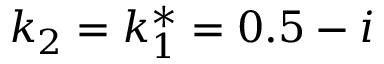<formula> <loc_0><loc_0><loc_500><loc_500>k _ { 2 } = k _ { 1 } ^ { * } = 0 . 5 - i</formula> 